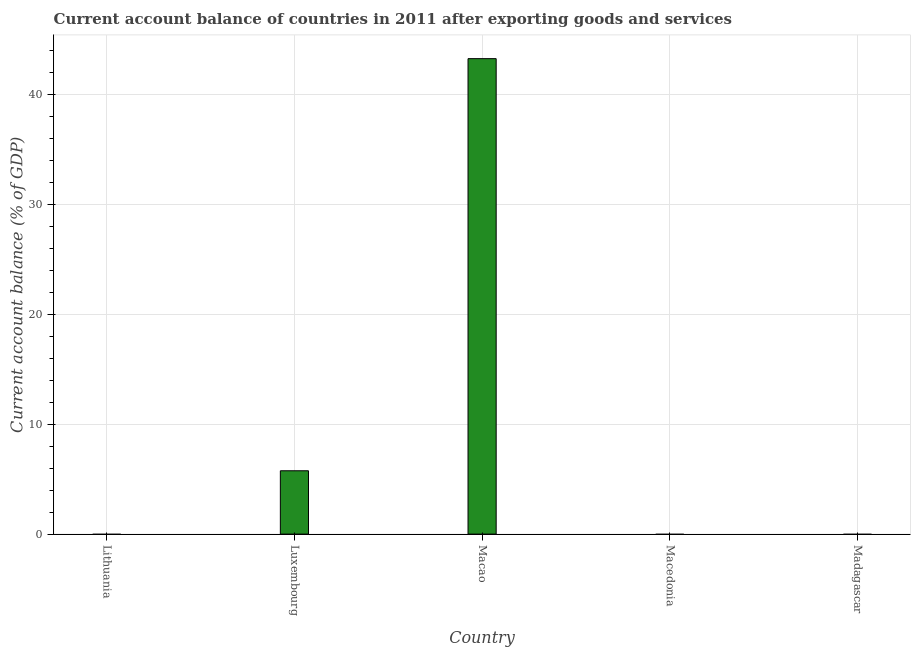Does the graph contain any zero values?
Your answer should be very brief. Yes. What is the title of the graph?
Offer a terse response. Current account balance of countries in 2011 after exporting goods and services. What is the label or title of the X-axis?
Provide a short and direct response. Country. What is the label or title of the Y-axis?
Your answer should be very brief. Current account balance (% of GDP). What is the current account balance in Luxembourg?
Offer a very short reply. 5.76. Across all countries, what is the maximum current account balance?
Your response must be concise. 43.27. Across all countries, what is the minimum current account balance?
Keep it short and to the point. 0. In which country was the current account balance maximum?
Offer a terse response. Macao. What is the sum of the current account balance?
Offer a very short reply. 49.04. What is the average current account balance per country?
Give a very brief answer. 9.81. What is the median current account balance?
Your answer should be compact. 0. In how many countries, is the current account balance greater than 42 %?
Offer a very short reply. 1. What is the ratio of the current account balance in Luxembourg to that in Macao?
Provide a short and direct response. 0.13. Is the sum of the current account balance in Luxembourg and Macao greater than the maximum current account balance across all countries?
Ensure brevity in your answer.  Yes. What is the difference between the highest and the lowest current account balance?
Provide a short and direct response. 43.27. Are all the bars in the graph horizontal?
Keep it short and to the point. No. What is the difference between two consecutive major ticks on the Y-axis?
Provide a succinct answer. 10. Are the values on the major ticks of Y-axis written in scientific E-notation?
Your answer should be compact. No. What is the Current account balance (% of GDP) in Lithuania?
Keep it short and to the point. 0. What is the Current account balance (% of GDP) in Luxembourg?
Give a very brief answer. 5.76. What is the Current account balance (% of GDP) in Macao?
Keep it short and to the point. 43.27. What is the Current account balance (% of GDP) in Macedonia?
Your response must be concise. 0. What is the difference between the Current account balance (% of GDP) in Luxembourg and Macao?
Your answer should be very brief. -37.51. What is the ratio of the Current account balance (% of GDP) in Luxembourg to that in Macao?
Your answer should be very brief. 0.13. 